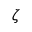Convert formula to latex. <formula><loc_0><loc_0><loc_500><loc_500>\zeta</formula> 